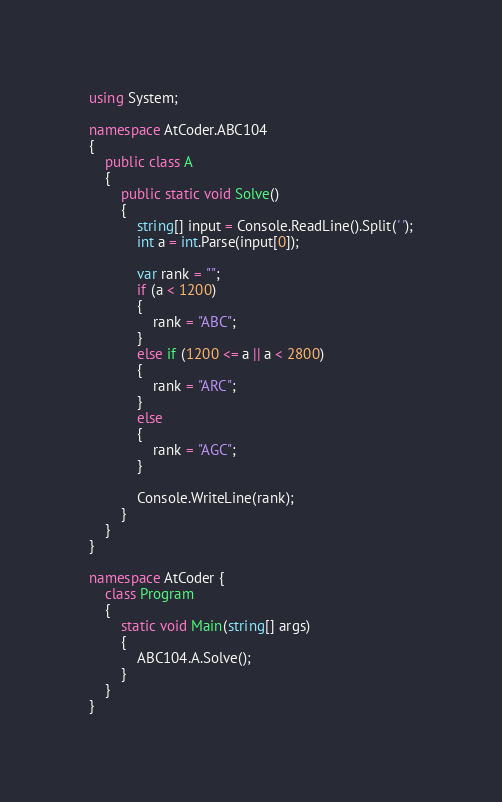<code> <loc_0><loc_0><loc_500><loc_500><_C#_>using System;

namespace AtCoder.ABC104
{
    public class A
    {
        public static void Solve()
        {
            string[] input = Console.ReadLine().Split(' ');
            int a = int.Parse(input[0]);

            var rank = ""; 
            if (a < 1200)
            {
                rank = "ABC";
            }
            else if (1200 <= a || a < 2800)
            {
                rank = "ARC";
            }
            else
            {
                rank = "AGC";
            }
            
            Console.WriteLine(rank);
        }    
    }
}

namespace AtCoder {
    class Program
    {
        static void Main(string[] args)
        {
            ABC104.A.Solve();
        }
    }
}
</code> 